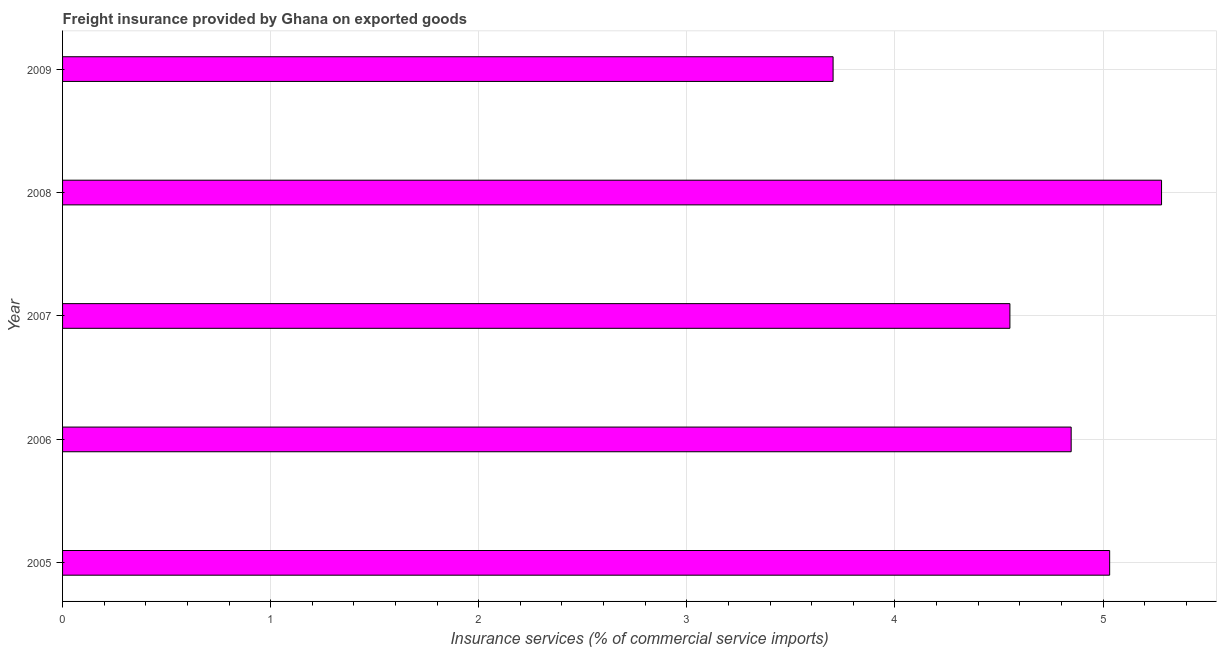Does the graph contain any zero values?
Provide a succinct answer. No. What is the title of the graph?
Provide a short and direct response. Freight insurance provided by Ghana on exported goods . What is the label or title of the X-axis?
Provide a short and direct response. Insurance services (% of commercial service imports). What is the label or title of the Y-axis?
Ensure brevity in your answer.  Year. What is the freight insurance in 2009?
Ensure brevity in your answer.  3.7. Across all years, what is the maximum freight insurance?
Offer a terse response. 5.28. Across all years, what is the minimum freight insurance?
Offer a very short reply. 3.7. In which year was the freight insurance minimum?
Provide a succinct answer. 2009. What is the sum of the freight insurance?
Your answer should be very brief. 23.42. What is the difference between the freight insurance in 2007 and 2008?
Your response must be concise. -0.73. What is the average freight insurance per year?
Give a very brief answer. 4.68. What is the median freight insurance?
Give a very brief answer. 4.85. In how many years, is the freight insurance greater than 0.2 %?
Make the answer very short. 5. What is the ratio of the freight insurance in 2006 to that in 2008?
Your answer should be very brief. 0.92. Is the freight insurance in 2005 less than that in 2007?
Provide a short and direct response. No. What is the difference between the highest and the second highest freight insurance?
Ensure brevity in your answer.  0.25. What is the difference between the highest and the lowest freight insurance?
Your answer should be very brief. 1.58. In how many years, is the freight insurance greater than the average freight insurance taken over all years?
Ensure brevity in your answer.  3. How many bars are there?
Make the answer very short. 5. How many years are there in the graph?
Offer a very short reply. 5. What is the Insurance services (% of commercial service imports) in 2005?
Your response must be concise. 5.03. What is the Insurance services (% of commercial service imports) of 2006?
Keep it short and to the point. 4.85. What is the Insurance services (% of commercial service imports) of 2007?
Offer a terse response. 4.55. What is the Insurance services (% of commercial service imports) in 2008?
Make the answer very short. 5.28. What is the Insurance services (% of commercial service imports) in 2009?
Offer a terse response. 3.7. What is the difference between the Insurance services (% of commercial service imports) in 2005 and 2006?
Make the answer very short. 0.18. What is the difference between the Insurance services (% of commercial service imports) in 2005 and 2007?
Offer a terse response. 0.48. What is the difference between the Insurance services (% of commercial service imports) in 2005 and 2008?
Your answer should be compact. -0.25. What is the difference between the Insurance services (% of commercial service imports) in 2005 and 2009?
Your answer should be very brief. 1.33. What is the difference between the Insurance services (% of commercial service imports) in 2006 and 2007?
Your answer should be compact. 0.29. What is the difference between the Insurance services (% of commercial service imports) in 2006 and 2008?
Ensure brevity in your answer.  -0.43. What is the difference between the Insurance services (% of commercial service imports) in 2006 and 2009?
Give a very brief answer. 1.14. What is the difference between the Insurance services (% of commercial service imports) in 2007 and 2008?
Ensure brevity in your answer.  -0.73. What is the difference between the Insurance services (% of commercial service imports) in 2007 and 2009?
Your answer should be compact. 0.85. What is the difference between the Insurance services (% of commercial service imports) in 2008 and 2009?
Ensure brevity in your answer.  1.58. What is the ratio of the Insurance services (% of commercial service imports) in 2005 to that in 2006?
Provide a short and direct response. 1.04. What is the ratio of the Insurance services (% of commercial service imports) in 2005 to that in 2007?
Keep it short and to the point. 1.1. What is the ratio of the Insurance services (% of commercial service imports) in 2005 to that in 2008?
Ensure brevity in your answer.  0.95. What is the ratio of the Insurance services (% of commercial service imports) in 2005 to that in 2009?
Your answer should be compact. 1.36. What is the ratio of the Insurance services (% of commercial service imports) in 2006 to that in 2007?
Your response must be concise. 1.06. What is the ratio of the Insurance services (% of commercial service imports) in 2006 to that in 2008?
Make the answer very short. 0.92. What is the ratio of the Insurance services (% of commercial service imports) in 2006 to that in 2009?
Provide a short and direct response. 1.31. What is the ratio of the Insurance services (% of commercial service imports) in 2007 to that in 2008?
Keep it short and to the point. 0.86. What is the ratio of the Insurance services (% of commercial service imports) in 2007 to that in 2009?
Keep it short and to the point. 1.23. What is the ratio of the Insurance services (% of commercial service imports) in 2008 to that in 2009?
Ensure brevity in your answer.  1.43. 